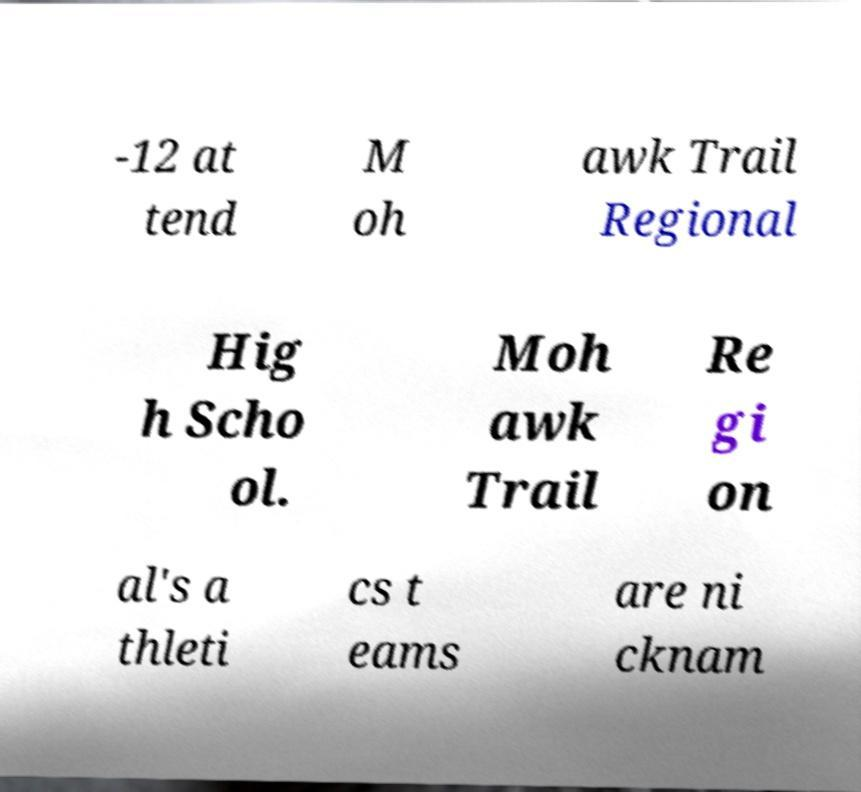There's text embedded in this image that I need extracted. Can you transcribe it verbatim? -12 at tend M oh awk Trail Regional Hig h Scho ol. Moh awk Trail Re gi on al's a thleti cs t eams are ni cknam 